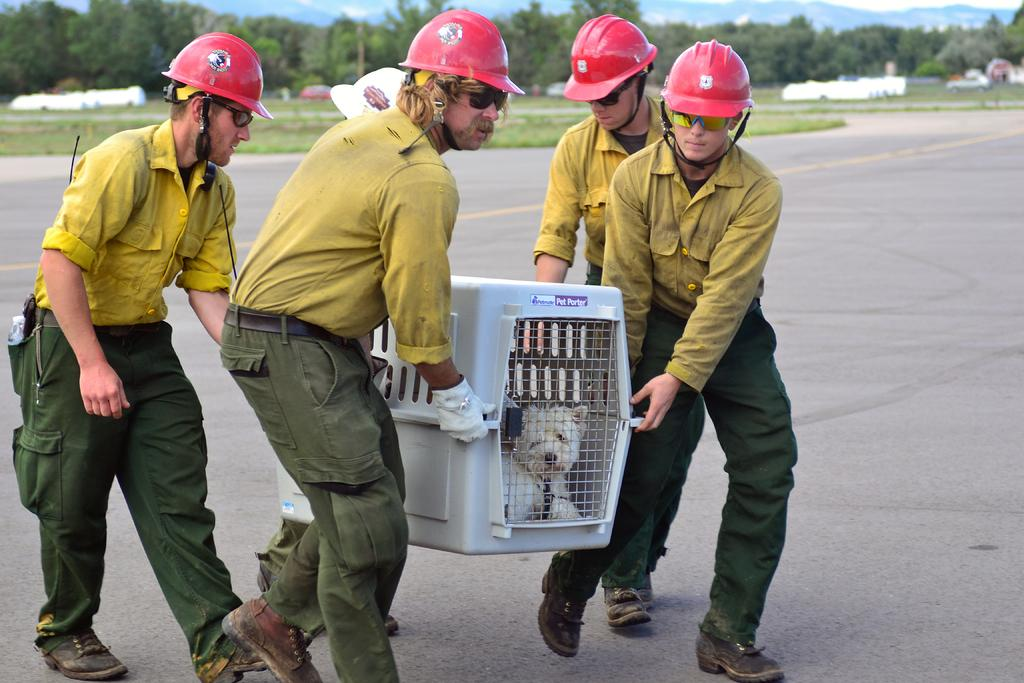How many people are present in the image? There are four people in the image. What are the people holding in the image? The people are holding a plastic box. What is inside the plastic box? There is a dog in the plastic box. What can be seen in the background of the image? There are trees, parked vehicles, and the sky visible in the background of the image. What type of popcorn is being shared among the people in the image? There is no popcorn present in the image. Can you tell me which person has the key to the dog's plastic box? There is no mention of a key or any locking mechanism for the plastic box in the image. 